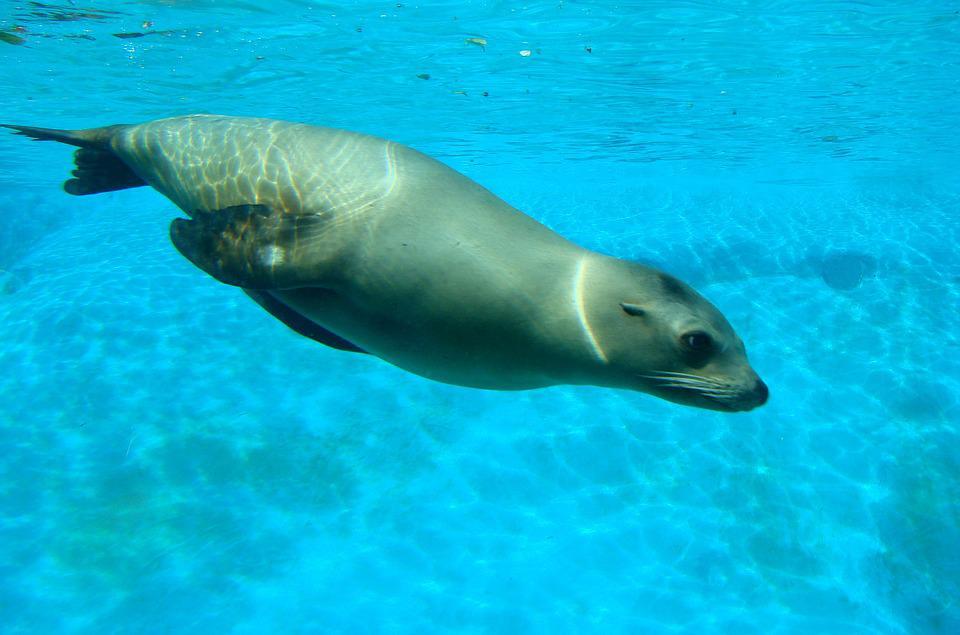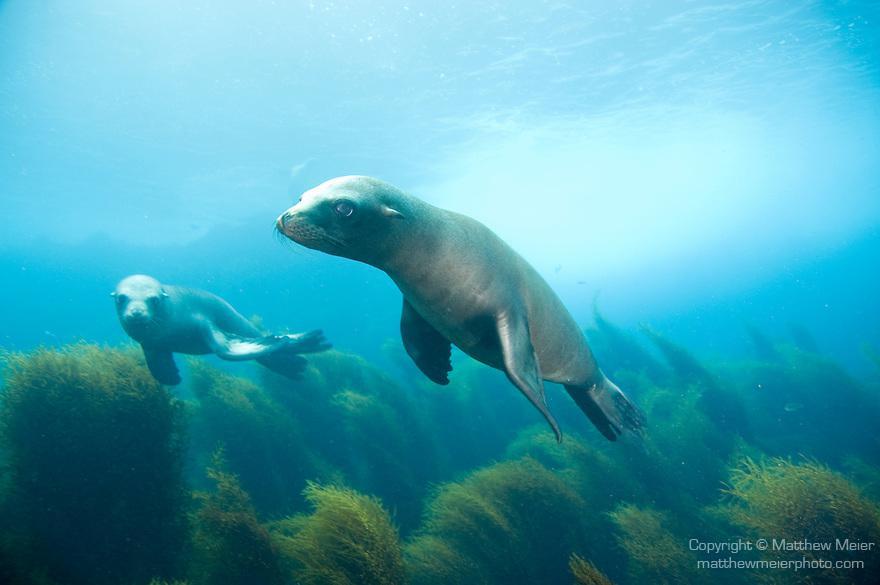The first image is the image on the left, the second image is the image on the right. Analyze the images presented: Is the assertion "We have two seals here, swimming." valid? Answer yes or no. No. The first image is the image on the left, the second image is the image on the right. Analyze the images presented: Is the assertion "there are two animals total" valid? Answer yes or no. No. 